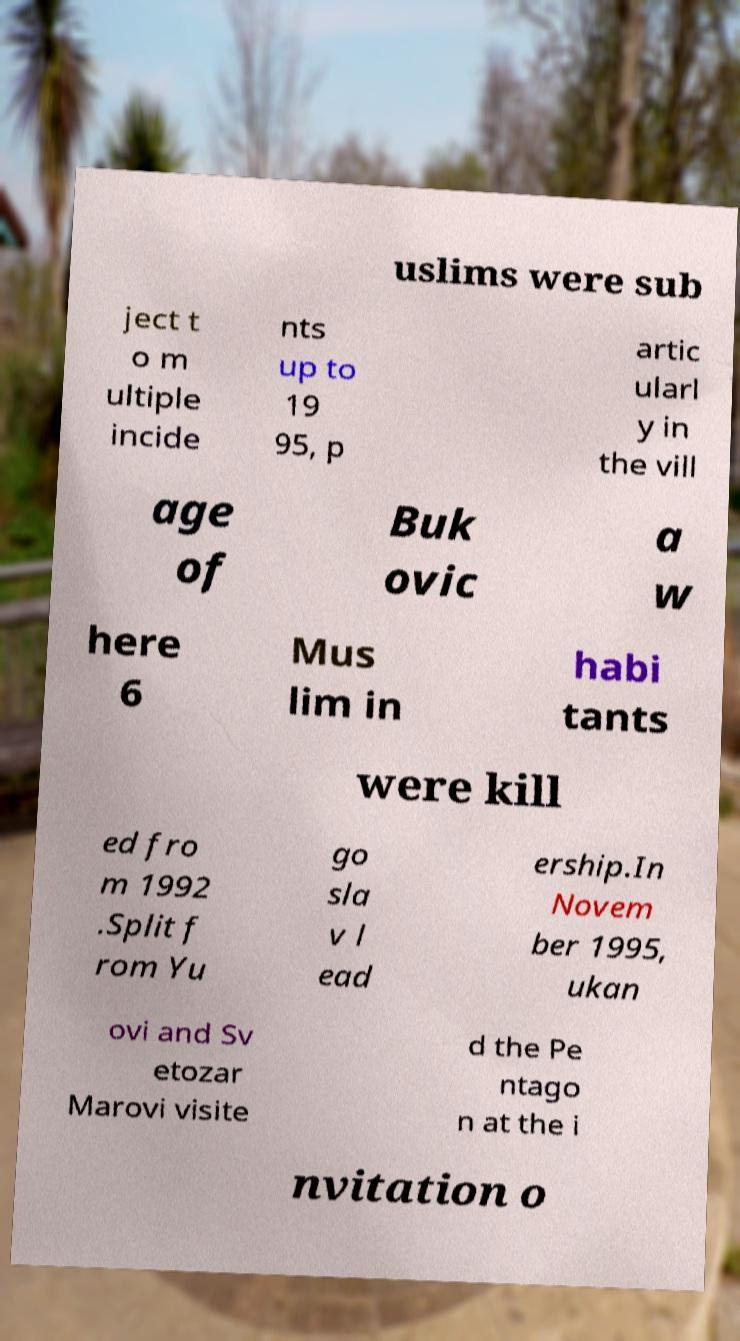For documentation purposes, I need the text within this image transcribed. Could you provide that? uslims were sub ject t o m ultiple incide nts up to 19 95, p artic ularl y in the vill age of Buk ovic a w here 6 Mus lim in habi tants were kill ed fro m 1992 .Split f rom Yu go sla v l ead ership.In Novem ber 1995, ukan ovi and Sv etozar Marovi visite d the Pe ntago n at the i nvitation o 